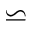Convert formula to latex. <formula><loc_0><loc_0><loc_500><loc_500>\backsimeq</formula> 